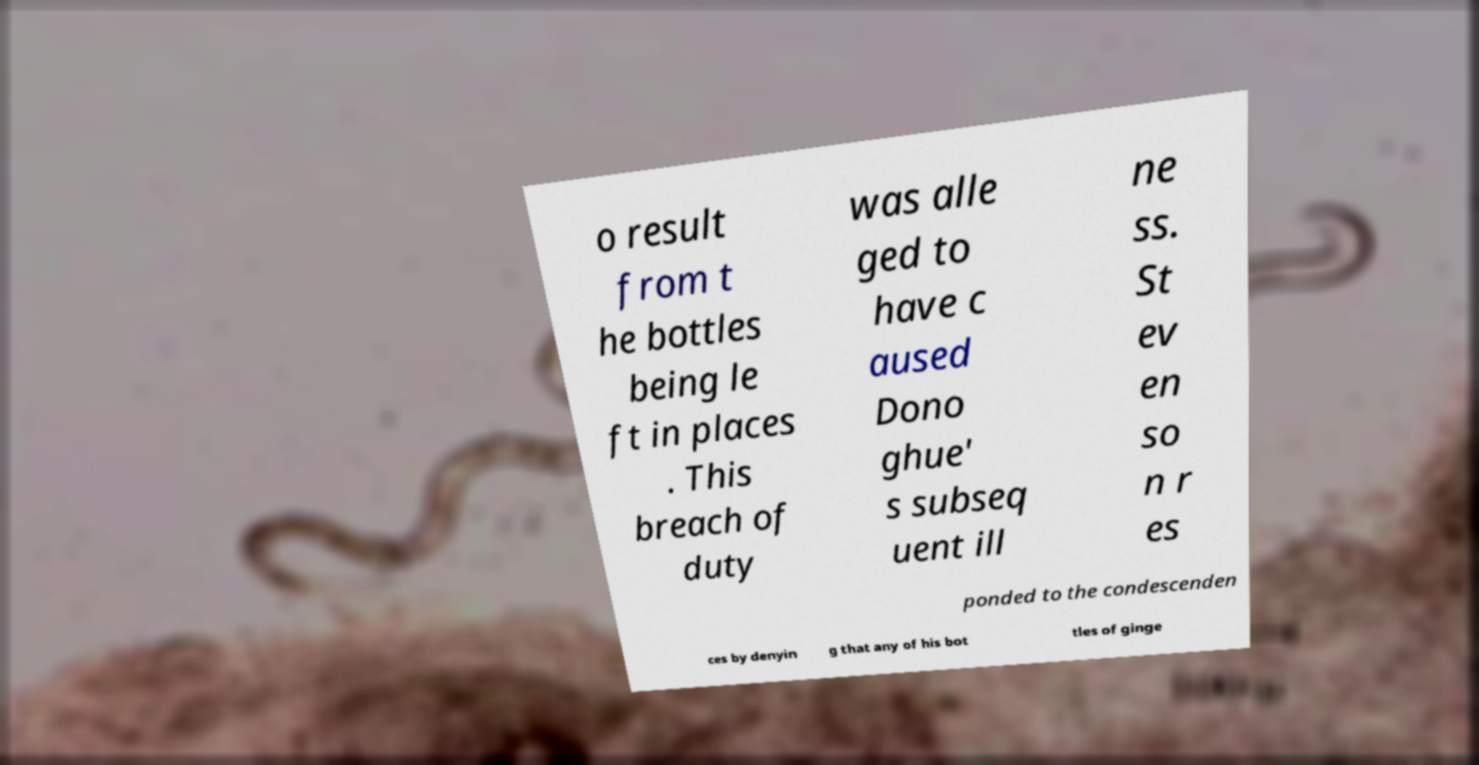I need the written content from this picture converted into text. Can you do that? o result from t he bottles being le ft in places . This breach of duty was alle ged to have c aused Dono ghue' s subseq uent ill ne ss. St ev en so n r es ponded to the condescenden ces by denyin g that any of his bot tles of ginge 